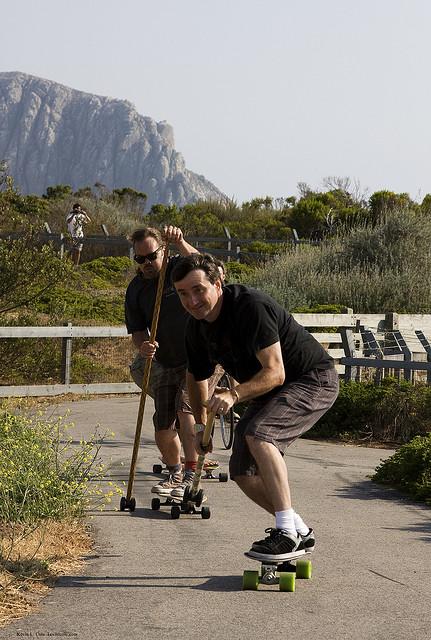Do you see the ocean?
Concise answer only. No. How many people are wearing sunglasses?
Short answer required. 1. How many are there on the skateboard?
Write a very short answer. 3. 